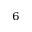Convert formula to latex. <formula><loc_0><loc_0><loc_500><loc_500>_ { 6 }</formula> 